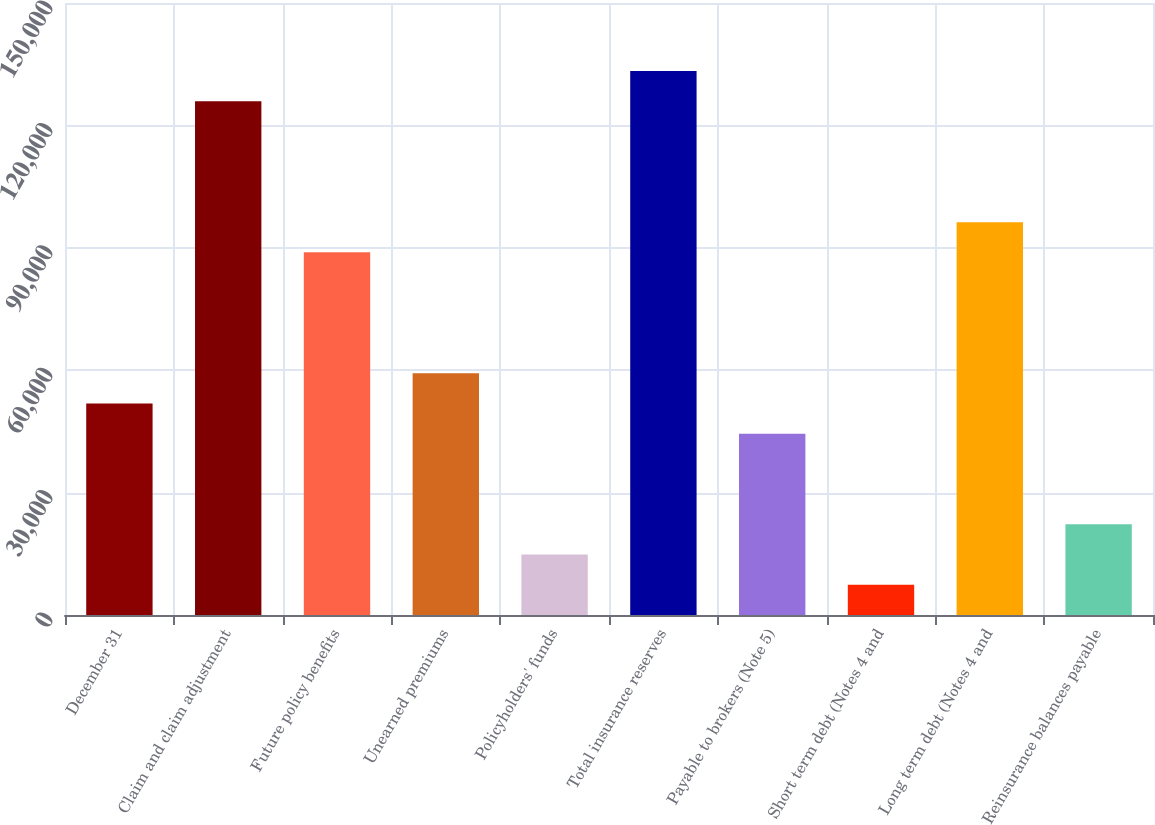<chart> <loc_0><loc_0><loc_500><loc_500><bar_chart><fcel>December 31<fcel>Claim and claim adjustment<fcel>Future policy benefits<fcel>Unearned premiums<fcel>Policyholders' funds<fcel>Total insurance reserves<fcel>Payable to brokers (Note 5)<fcel>Short term debt (Notes 4 and<fcel>Long term debt (Notes 4 and<fcel>Reinsurance balances payable<nl><fcel>51850.2<fcel>125916<fcel>88883.2<fcel>59256.8<fcel>14817.2<fcel>133323<fcel>44443.6<fcel>7410.6<fcel>96289.8<fcel>22223.8<nl></chart> 